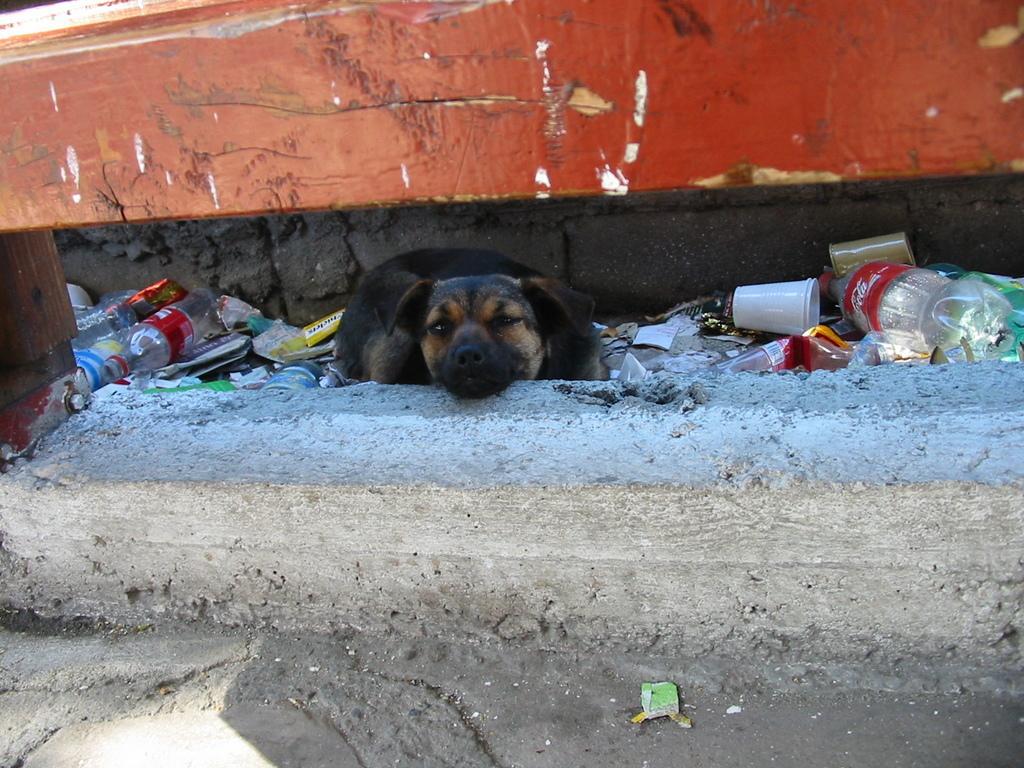How would you summarize this image in a sentence or two? In this image I can see the dog in black and cream color and I can also see few glasses, bottles. In the background the wall is in brown color. 